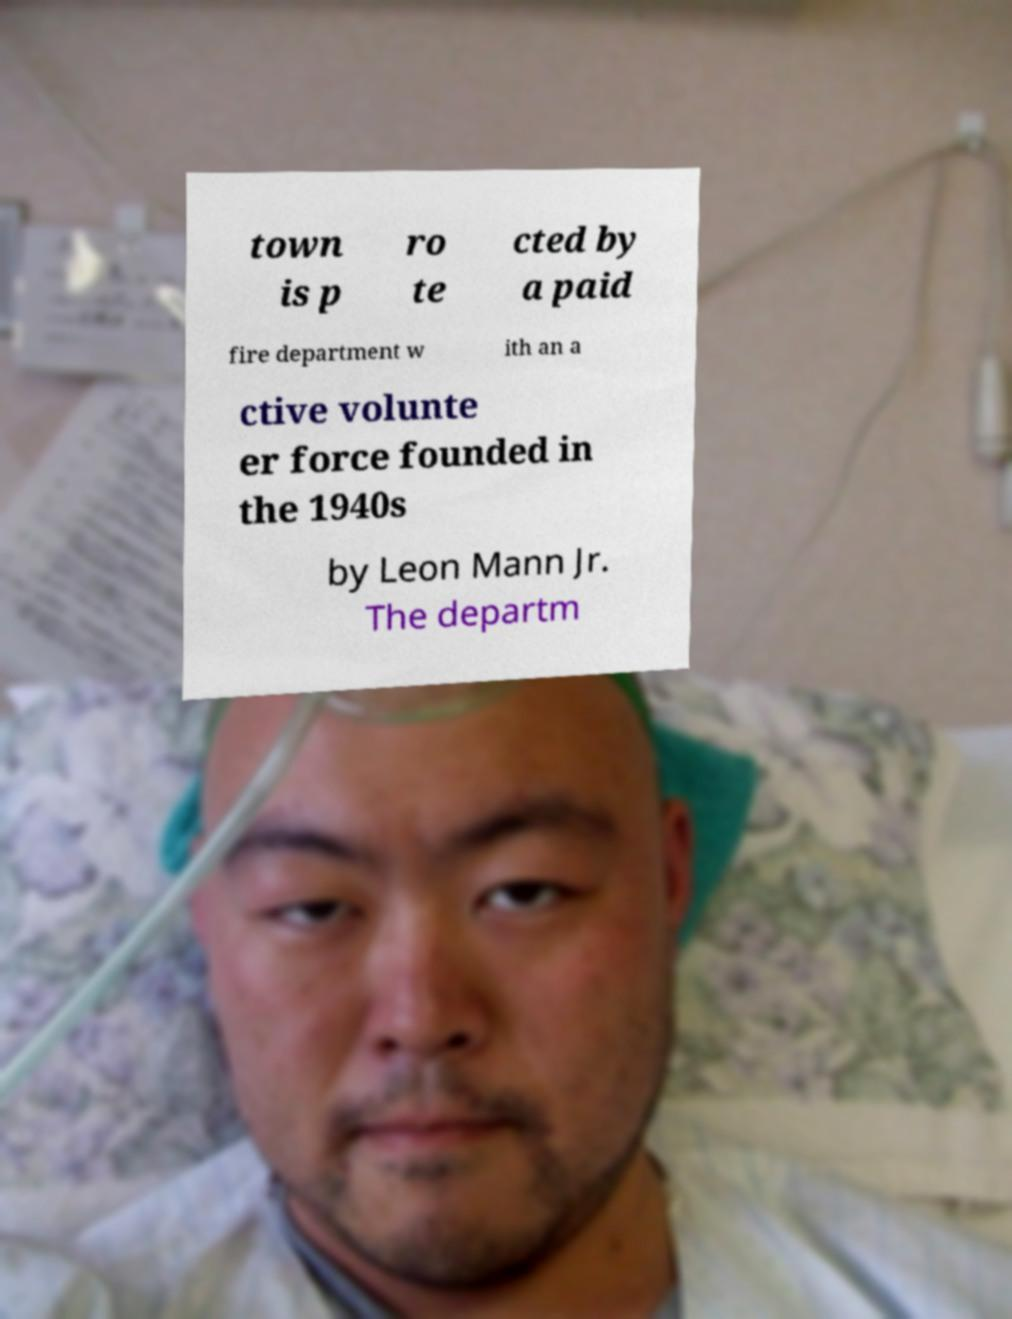Can you read and provide the text displayed in the image?This photo seems to have some interesting text. Can you extract and type it out for me? town is p ro te cted by a paid fire department w ith an a ctive volunte er force founded in the 1940s by Leon Mann Jr. The departm 